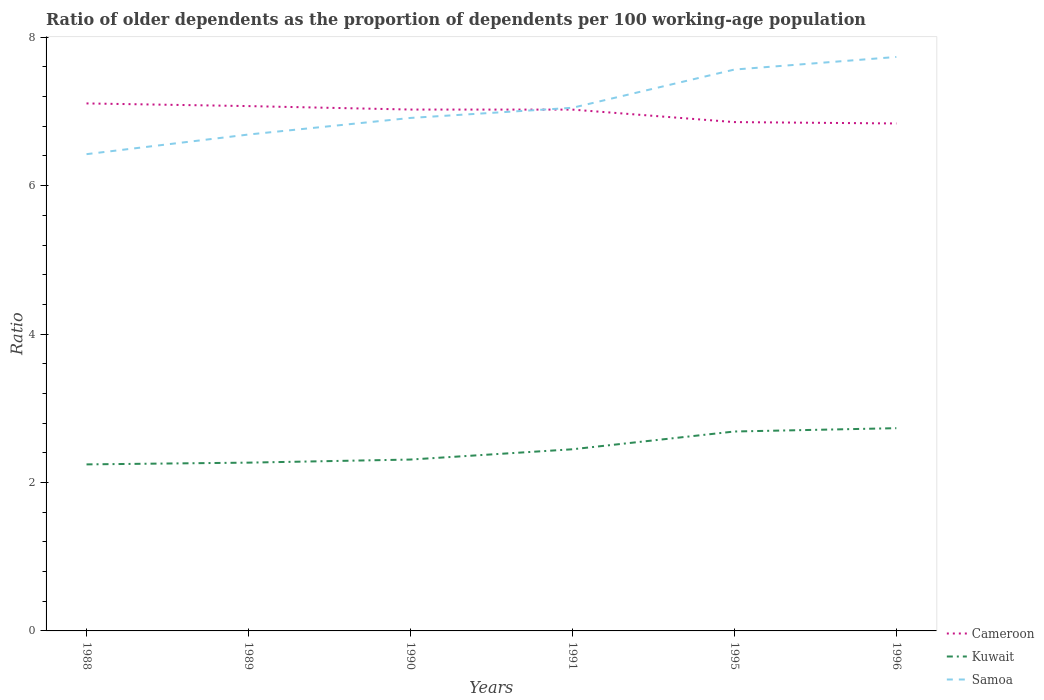How many different coloured lines are there?
Keep it short and to the point. 3. Is the number of lines equal to the number of legend labels?
Your answer should be very brief. Yes. Across all years, what is the maximum age dependency ratio(old) in Cameroon?
Provide a succinct answer. 6.84. In which year was the age dependency ratio(old) in Kuwait maximum?
Your response must be concise. 1988. What is the total age dependency ratio(old) in Kuwait in the graph?
Provide a short and direct response. -0.42. What is the difference between the highest and the second highest age dependency ratio(old) in Samoa?
Your answer should be very brief. 1.31. What is the difference between the highest and the lowest age dependency ratio(old) in Kuwait?
Ensure brevity in your answer.  2. How many years are there in the graph?
Make the answer very short. 6. What is the difference between two consecutive major ticks on the Y-axis?
Offer a terse response. 2. Are the values on the major ticks of Y-axis written in scientific E-notation?
Your answer should be very brief. No. Does the graph contain grids?
Ensure brevity in your answer.  No. How many legend labels are there?
Provide a short and direct response. 3. What is the title of the graph?
Give a very brief answer. Ratio of older dependents as the proportion of dependents per 100 working-age population. What is the label or title of the Y-axis?
Provide a succinct answer. Ratio. What is the Ratio in Cameroon in 1988?
Keep it short and to the point. 7.11. What is the Ratio of Kuwait in 1988?
Ensure brevity in your answer.  2.24. What is the Ratio of Samoa in 1988?
Ensure brevity in your answer.  6.42. What is the Ratio of Cameroon in 1989?
Your answer should be very brief. 7.07. What is the Ratio of Kuwait in 1989?
Offer a very short reply. 2.27. What is the Ratio in Samoa in 1989?
Your response must be concise. 6.69. What is the Ratio of Cameroon in 1990?
Provide a succinct answer. 7.03. What is the Ratio of Kuwait in 1990?
Your answer should be very brief. 2.31. What is the Ratio in Samoa in 1990?
Offer a very short reply. 6.91. What is the Ratio of Cameroon in 1991?
Your answer should be very brief. 7.03. What is the Ratio of Kuwait in 1991?
Provide a succinct answer. 2.45. What is the Ratio in Samoa in 1991?
Provide a succinct answer. 7.05. What is the Ratio of Cameroon in 1995?
Provide a succinct answer. 6.86. What is the Ratio in Kuwait in 1995?
Keep it short and to the point. 2.69. What is the Ratio in Samoa in 1995?
Provide a short and direct response. 7.56. What is the Ratio of Cameroon in 1996?
Your response must be concise. 6.84. What is the Ratio of Kuwait in 1996?
Keep it short and to the point. 2.73. What is the Ratio in Samoa in 1996?
Provide a short and direct response. 7.73. Across all years, what is the maximum Ratio of Cameroon?
Offer a terse response. 7.11. Across all years, what is the maximum Ratio of Kuwait?
Give a very brief answer. 2.73. Across all years, what is the maximum Ratio in Samoa?
Offer a terse response. 7.73. Across all years, what is the minimum Ratio in Cameroon?
Your answer should be compact. 6.84. Across all years, what is the minimum Ratio in Kuwait?
Your response must be concise. 2.24. Across all years, what is the minimum Ratio in Samoa?
Provide a succinct answer. 6.42. What is the total Ratio in Cameroon in the graph?
Ensure brevity in your answer.  41.93. What is the total Ratio of Kuwait in the graph?
Your answer should be compact. 14.69. What is the total Ratio in Samoa in the graph?
Offer a terse response. 42.38. What is the difference between the Ratio of Cameroon in 1988 and that in 1989?
Give a very brief answer. 0.04. What is the difference between the Ratio of Kuwait in 1988 and that in 1989?
Offer a very short reply. -0.02. What is the difference between the Ratio in Samoa in 1988 and that in 1989?
Provide a short and direct response. -0.26. What is the difference between the Ratio in Cameroon in 1988 and that in 1990?
Offer a terse response. 0.08. What is the difference between the Ratio in Kuwait in 1988 and that in 1990?
Give a very brief answer. -0.07. What is the difference between the Ratio in Samoa in 1988 and that in 1990?
Provide a succinct answer. -0.49. What is the difference between the Ratio in Cameroon in 1988 and that in 1991?
Provide a succinct answer. 0.08. What is the difference between the Ratio in Kuwait in 1988 and that in 1991?
Give a very brief answer. -0.2. What is the difference between the Ratio in Samoa in 1988 and that in 1991?
Keep it short and to the point. -0.62. What is the difference between the Ratio in Cameroon in 1988 and that in 1995?
Your answer should be very brief. 0.25. What is the difference between the Ratio of Kuwait in 1988 and that in 1995?
Make the answer very short. -0.44. What is the difference between the Ratio in Samoa in 1988 and that in 1995?
Offer a very short reply. -1.14. What is the difference between the Ratio in Cameroon in 1988 and that in 1996?
Your answer should be very brief. 0.27. What is the difference between the Ratio in Kuwait in 1988 and that in 1996?
Offer a terse response. -0.49. What is the difference between the Ratio of Samoa in 1988 and that in 1996?
Offer a very short reply. -1.31. What is the difference between the Ratio of Cameroon in 1989 and that in 1990?
Keep it short and to the point. 0.05. What is the difference between the Ratio of Kuwait in 1989 and that in 1990?
Your answer should be very brief. -0.04. What is the difference between the Ratio in Samoa in 1989 and that in 1990?
Provide a succinct answer. -0.22. What is the difference between the Ratio in Cameroon in 1989 and that in 1991?
Provide a short and direct response. 0.05. What is the difference between the Ratio of Kuwait in 1989 and that in 1991?
Provide a succinct answer. -0.18. What is the difference between the Ratio in Samoa in 1989 and that in 1991?
Keep it short and to the point. -0.36. What is the difference between the Ratio of Cameroon in 1989 and that in 1995?
Offer a very short reply. 0.22. What is the difference between the Ratio of Kuwait in 1989 and that in 1995?
Make the answer very short. -0.42. What is the difference between the Ratio in Samoa in 1989 and that in 1995?
Offer a very short reply. -0.88. What is the difference between the Ratio in Cameroon in 1989 and that in 1996?
Your answer should be very brief. 0.23. What is the difference between the Ratio of Kuwait in 1989 and that in 1996?
Provide a short and direct response. -0.46. What is the difference between the Ratio of Samoa in 1989 and that in 1996?
Give a very brief answer. -1.05. What is the difference between the Ratio in Cameroon in 1990 and that in 1991?
Ensure brevity in your answer.  0. What is the difference between the Ratio in Kuwait in 1990 and that in 1991?
Provide a short and direct response. -0.14. What is the difference between the Ratio of Samoa in 1990 and that in 1991?
Your answer should be very brief. -0.14. What is the difference between the Ratio of Cameroon in 1990 and that in 1995?
Keep it short and to the point. 0.17. What is the difference between the Ratio of Kuwait in 1990 and that in 1995?
Give a very brief answer. -0.38. What is the difference between the Ratio in Samoa in 1990 and that in 1995?
Your response must be concise. -0.65. What is the difference between the Ratio in Cameroon in 1990 and that in 1996?
Give a very brief answer. 0.19. What is the difference between the Ratio of Kuwait in 1990 and that in 1996?
Your answer should be very brief. -0.42. What is the difference between the Ratio in Samoa in 1990 and that in 1996?
Offer a very short reply. -0.82. What is the difference between the Ratio in Cameroon in 1991 and that in 1995?
Your response must be concise. 0.17. What is the difference between the Ratio in Kuwait in 1991 and that in 1995?
Offer a terse response. -0.24. What is the difference between the Ratio of Samoa in 1991 and that in 1995?
Provide a succinct answer. -0.52. What is the difference between the Ratio of Cameroon in 1991 and that in 1996?
Keep it short and to the point. 0.19. What is the difference between the Ratio of Kuwait in 1991 and that in 1996?
Provide a succinct answer. -0.28. What is the difference between the Ratio of Samoa in 1991 and that in 1996?
Give a very brief answer. -0.69. What is the difference between the Ratio of Cameroon in 1995 and that in 1996?
Your response must be concise. 0.02. What is the difference between the Ratio of Kuwait in 1995 and that in 1996?
Your response must be concise. -0.04. What is the difference between the Ratio in Samoa in 1995 and that in 1996?
Your answer should be very brief. -0.17. What is the difference between the Ratio of Cameroon in 1988 and the Ratio of Kuwait in 1989?
Keep it short and to the point. 4.84. What is the difference between the Ratio of Cameroon in 1988 and the Ratio of Samoa in 1989?
Provide a succinct answer. 0.42. What is the difference between the Ratio of Kuwait in 1988 and the Ratio of Samoa in 1989?
Ensure brevity in your answer.  -4.45. What is the difference between the Ratio in Cameroon in 1988 and the Ratio in Kuwait in 1990?
Provide a short and direct response. 4.8. What is the difference between the Ratio of Cameroon in 1988 and the Ratio of Samoa in 1990?
Keep it short and to the point. 0.2. What is the difference between the Ratio of Kuwait in 1988 and the Ratio of Samoa in 1990?
Offer a terse response. -4.67. What is the difference between the Ratio of Cameroon in 1988 and the Ratio of Kuwait in 1991?
Keep it short and to the point. 4.66. What is the difference between the Ratio in Cameroon in 1988 and the Ratio in Samoa in 1991?
Offer a very short reply. 0.06. What is the difference between the Ratio in Kuwait in 1988 and the Ratio in Samoa in 1991?
Offer a terse response. -4.81. What is the difference between the Ratio of Cameroon in 1988 and the Ratio of Kuwait in 1995?
Provide a short and direct response. 4.42. What is the difference between the Ratio of Cameroon in 1988 and the Ratio of Samoa in 1995?
Make the answer very short. -0.46. What is the difference between the Ratio in Kuwait in 1988 and the Ratio in Samoa in 1995?
Provide a succinct answer. -5.32. What is the difference between the Ratio of Cameroon in 1988 and the Ratio of Kuwait in 1996?
Provide a short and direct response. 4.38. What is the difference between the Ratio of Cameroon in 1988 and the Ratio of Samoa in 1996?
Offer a very short reply. -0.63. What is the difference between the Ratio of Kuwait in 1988 and the Ratio of Samoa in 1996?
Your answer should be compact. -5.49. What is the difference between the Ratio in Cameroon in 1989 and the Ratio in Kuwait in 1990?
Keep it short and to the point. 4.76. What is the difference between the Ratio of Cameroon in 1989 and the Ratio of Samoa in 1990?
Give a very brief answer. 0.16. What is the difference between the Ratio in Kuwait in 1989 and the Ratio in Samoa in 1990?
Keep it short and to the point. -4.64. What is the difference between the Ratio of Cameroon in 1989 and the Ratio of Kuwait in 1991?
Your response must be concise. 4.62. What is the difference between the Ratio of Cameroon in 1989 and the Ratio of Samoa in 1991?
Your response must be concise. 0.02. What is the difference between the Ratio in Kuwait in 1989 and the Ratio in Samoa in 1991?
Your answer should be very brief. -4.78. What is the difference between the Ratio of Cameroon in 1989 and the Ratio of Kuwait in 1995?
Offer a terse response. 4.39. What is the difference between the Ratio of Cameroon in 1989 and the Ratio of Samoa in 1995?
Your answer should be compact. -0.49. What is the difference between the Ratio in Kuwait in 1989 and the Ratio in Samoa in 1995?
Offer a terse response. -5.3. What is the difference between the Ratio in Cameroon in 1989 and the Ratio in Kuwait in 1996?
Provide a short and direct response. 4.34. What is the difference between the Ratio in Cameroon in 1989 and the Ratio in Samoa in 1996?
Make the answer very short. -0.66. What is the difference between the Ratio of Kuwait in 1989 and the Ratio of Samoa in 1996?
Offer a terse response. -5.47. What is the difference between the Ratio in Cameroon in 1990 and the Ratio in Kuwait in 1991?
Offer a very short reply. 4.58. What is the difference between the Ratio in Cameroon in 1990 and the Ratio in Samoa in 1991?
Provide a succinct answer. -0.02. What is the difference between the Ratio in Kuwait in 1990 and the Ratio in Samoa in 1991?
Provide a short and direct response. -4.74. What is the difference between the Ratio in Cameroon in 1990 and the Ratio in Kuwait in 1995?
Your answer should be compact. 4.34. What is the difference between the Ratio of Cameroon in 1990 and the Ratio of Samoa in 1995?
Offer a very short reply. -0.54. What is the difference between the Ratio in Kuwait in 1990 and the Ratio in Samoa in 1995?
Your response must be concise. -5.26. What is the difference between the Ratio in Cameroon in 1990 and the Ratio in Kuwait in 1996?
Your answer should be very brief. 4.29. What is the difference between the Ratio of Cameroon in 1990 and the Ratio of Samoa in 1996?
Your answer should be very brief. -0.71. What is the difference between the Ratio of Kuwait in 1990 and the Ratio of Samoa in 1996?
Give a very brief answer. -5.43. What is the difference between the Ratio in Cameroon in 1991 and the Ratio in Kuwait in 1995?
Ensure brevity in your answer.  4.34. What is the difference between the Ratio in Cameroon in 1991 and the Ratio in Samoa in 1995?
Ensure brevity in your answer.  -0.54. What is the difference between the Ratio in Kuwait in 1991 and the Ratio in Samoa in 1995?
Your response must be concise. -5.12. What is the difference between the Ratio of Cameroon in 1991 and the Ratio of Kuwait in 1996?
Give a very brief answer. 4.29. What is the difference between the Ratio of Cameroon in 1991 and the Ratio of Samoa in 1996?
Give a very brief answer. -0.71. What is the difference between the Ratio of Kuwait in 1991 and the Ratio of Samoa in 1996?
Offer a very short reply. -5.29. What is the difference between the Ratio in Cameroon in 1995 and the Ratio in Kuwait in 1996?
Your answer should be very brief. 4.12. What is the difference between the Ratio in Cameroon in 1995 and the Ratio in Samoa in 1996?
Offer a very short reply. -0.88. What is the difference between the Ratio of Kuwait in 1995 and the Ratio of Samoa in 1996?
Provide a short and direct response. -5.05. What is the average Ratio in Cameroon per year?
Your answer should be very brief. 6.99. What is the average Ratio of Kuwait per year?
Give a very brief answer. 2.45. What is the average Ratio in Samoa per year?
Provide a short and direct response. 7.06. In the year 1988, what is the difference between the Ratio in Cameroon and Ratio in Kuwait?
Give a very brief answer. 4.86. In the year 1988, what is the difference between the Ratio in Cameroon and Ratio in Samoa?
Keep it short and to the point. 0.68. In the year 1988, what is the difference between the Ratio in Kuwait and Ratio in Samoa?
Provide a succinct answer. -4.18. In the year 1989, what is the difference between the Ratio in Cameroon and Ratio in Kuwait?
Provide a short and direct response. 4.8. In the year 1989, what is the difference between the Ratio of Cameroon and Ratio of Samoa?
Your answer should be very brief. 0.38. In the year 1989, what is the difference between the Ratio in Kuwait and Ratio in Samoa?
Ensure brevity in your answer.  -4.42. In the year 1990, what is the difference between the Ratio of Cameroon and Ratio of Kuwait?
Your answer should be very brief. 4.72. In the year 1990, what is the difference between the Ratio of Cameroon and Ratio of Samoa?
Ensure brevity in your answer.  0.11. In the year 1990, what is the difference between the Ratio of Kuwait and Ratio of Samoa?
Offer a very short reply. -4.6. In the year 1991, what is the difference between the Ratio of Cameroon and Ratio of Kuwait?
Make the answer very short. 4.58. In the year 1991, what is the difference between the Ratio in Cameroon and Ratio in Samoa?
Give a very brief answer. -0.02. In the year 1991, what is the difference between the Ratio of Kuwait and Ratio of Samoa?
Provide a succinct answer. -4.6. In the year 1995, what is the difference between the Ratio in Cameroon and Ratio in Kuwait?
Your answer should be very brief. 4.17. In the year 1995, what is the difference between the Ratio in Cameroon and Ratio in Samoa?
Your answer should be compact. -0.71. In the year 1995, what is the difference between the Ratio of Kuwait and Ratio of Samoa?
Make the answer very short. -4.88. In the year 1996, what is the difference between the Ratio of Cameroon and Ratio of Kuwait?
Your answer should be compact. 4.11. In the year 1996, what is the difference between the Ratio in Cameroon and Ratio in Samoa?
Offer a very short reply. -0.9. In the year 1996, what is the difference between the Ratio in Kuwait and Ratio in Samoa?
Keep it short and to the point. -5. What is the ratio of the Ratio of Cameroon in 1988 to that in 1989?
Your response must be concise. 1.01. What is the ratio of the Ratio in Samoa in 1988 to that in 1989?
Make the answer very short. 0.96. What is the ratio of the Ratio in Cameroon in 1988 to that in 1990?
Your answer should be compact. 1.01. What is the ratio of the Ratio of Kuwait in 1988 to that in 1990?
Provide a succinct answer. 0.97. What is the ratio of the Ratio in Samoa in 1988 to that in 1990?
Your response must be concise. 0.93. What is the ratio of the Ratio in Cameroon in 1988 to that in 1991?
Provide a short and direct response. 1.01. What is the ratio of the Ratio of Kuwait in 1988 to that in 1991?
Give a very brief answer. 0.92. What is the ratio of the Ratio of Samoa in 1988 to that in 1991?
Your answer should be compact. 0.91. What is the ratio of the Ratio of Cameroon in 1988 to that in 1995?
Give a very brief answer. 1.04. What is the ratio of the Ratio of Kuwait in 1988 to that in 1995?
Offer a terse response. 0.84. What is the ratio of the Ratio in Samoa in 1988 to that in 1995?
Ensure brevity in your answer.  0.85. What is the ratio of the Ratio of Cameroon in 1988 to that in 1996?
Offer a very short reply. 1.04. What is the ratio of the Ratio in Kuwait in 1988 to that in 1996?
Keep it short and to the point. 0.82. What is the ratio of the Ratio of Samoa in 1988 to that in 1996?
Offer a terse response. 0.83. What is the ratio of the Ratio in Cameroon in 1989 to that in 1990?
Offer a terse response. 1.01. What is the ratio of the Ratio in Kuwait in 1989 to that in 1990?
Provide a short and direct response. 0.98. What is the ratio of the Ratio in Samoa in 1989 to that in 1990?
Offer a very short reply. 0.97. What is the ratio of the Ratio in Cameroon in 1989 to that in 1991?
Offer a terse response. 1.01. What is the ratio of the Ratio of Kuwait in 1989 to that in 1991?
Keep it short and to the point. 0.93. What is the ratio of the Ratio of Samoa in 1989 to that in 1991?
Offer a terse response. 0.95. What is the ratio of the Ratio in Cameroon in 1989 to that in 1995?
Make the answer very short. 1.03. What is the ratio of the Ratio in Kuwait in 1989 to that in 1995?
Give a very brief answer. 0.84. What is the ratio of the Ratio of Samoa in 1989 to that in 1995?
Your response must be concise. 0.88. What is the ratio of the Ratio of Cameroon in 1989 to that in 1996?
Keep it short and to the point. 1.03. What is the ratio of the Ratio in Kuwait in 1989 to that in 1996?
Keep it short and to the point. 0.83. What is the ratio of the Ratio of Samoa in 1989 to that in 1996?
Offer a terse response. 0.86. What is the ratio of the Ratio in Cameroon in 1990 to that in 1991?
Make the answer very short. 1. What is the ratio of the Ratio in Kuwait in 1990 to that in 1991?
Offer a terse response. 0.94. What is the ratio of the Ratio in Samoa in 1990 to that in 1991?
Provide a short and direct response. 0.98. What is the ratio of the Ratio in Cameroon in 1990 to that in 1995?
Make the answer very short. 1.02. What is the ratio of the Ratio in Kuwait in 1990 to that in 1995?
Keep it short and to the point. 0.86. What is the ratio of the Ratio of Samoa in 1990 to that in 1995?
Provide a short and direct response. 0.91. What is the ratio of the Ratio in Cameroon in 1990 to that in 1996?
Make the answer very short. 1.03. What is the ratio of the Ratio of Kuwait in 1990 to that in 1996?
Provide a succinct answer. 0.85. What is the ratio of the Ratio in Samoa in 1990 to that in 1996?
Your answer should be compact. 0.89. What is the ratio of the Ratio in Cameroon in 1991 to that in 1995?
Ensure brevity in your answer.  1.02. What is the ratio of the Ratio in Kuwait in 1991 to that in 1995?
Your answer should be very brief. 0.91. What is the ratio of the Ratio in Samoa in 1991 to that in 1995?
Provide a short and direct response. 0.93. What is the ratio of the Ratio of Cameroon in 1991 to that in 1996?
Your answer should be compact. 1.03. What is the ratio of the Ratio in Kuwait in 1991 to that in 1996?
Give a very brief answer. 0.9. What is the ratio of the Ratio of Samoa in 1991 to that in 1996?
Your answer should be very brief. 0.91. What is the ratio of the Ratio in Kuwait in 1995 to that in 1996?
Your response must be concise. 0.98. What is the difference between the highest and the second highest Ratio in Cameroon?
Your answer should be compact. 0.04. What is the difference between the highest and the second highest Ratio in Kuwait?
Your answer should be compact. 0.04. What is the difference between the highest and the second highest Ratio of Samoa?
Your response must be concise. 0.17. What is the difference between the highest and the lowest Ratio in Cameroon?
Your response must be concise. 0.27. What is the difference between the highest and the lowest Ratio in Kuwait?
Make the answer very short. 0.49. What is the difference between the highest and the lowest Ratio in Samoa?
Your answer should be very brief. 1.31. 